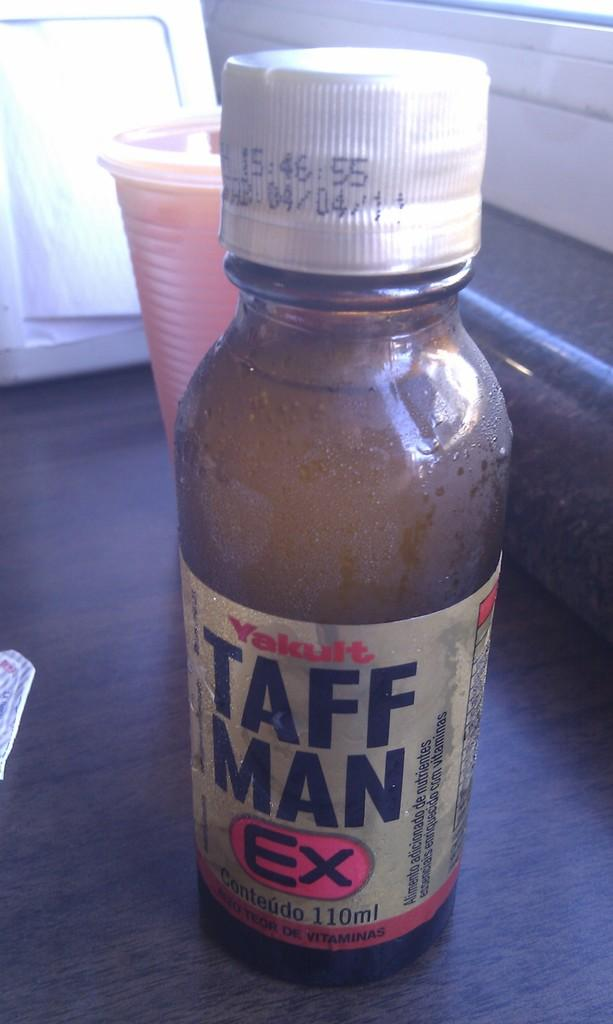<image>
Render a clear and concise summary of the photo. Taffman Ex bottle that says Conteudo 110 ML from the company Yakult. 